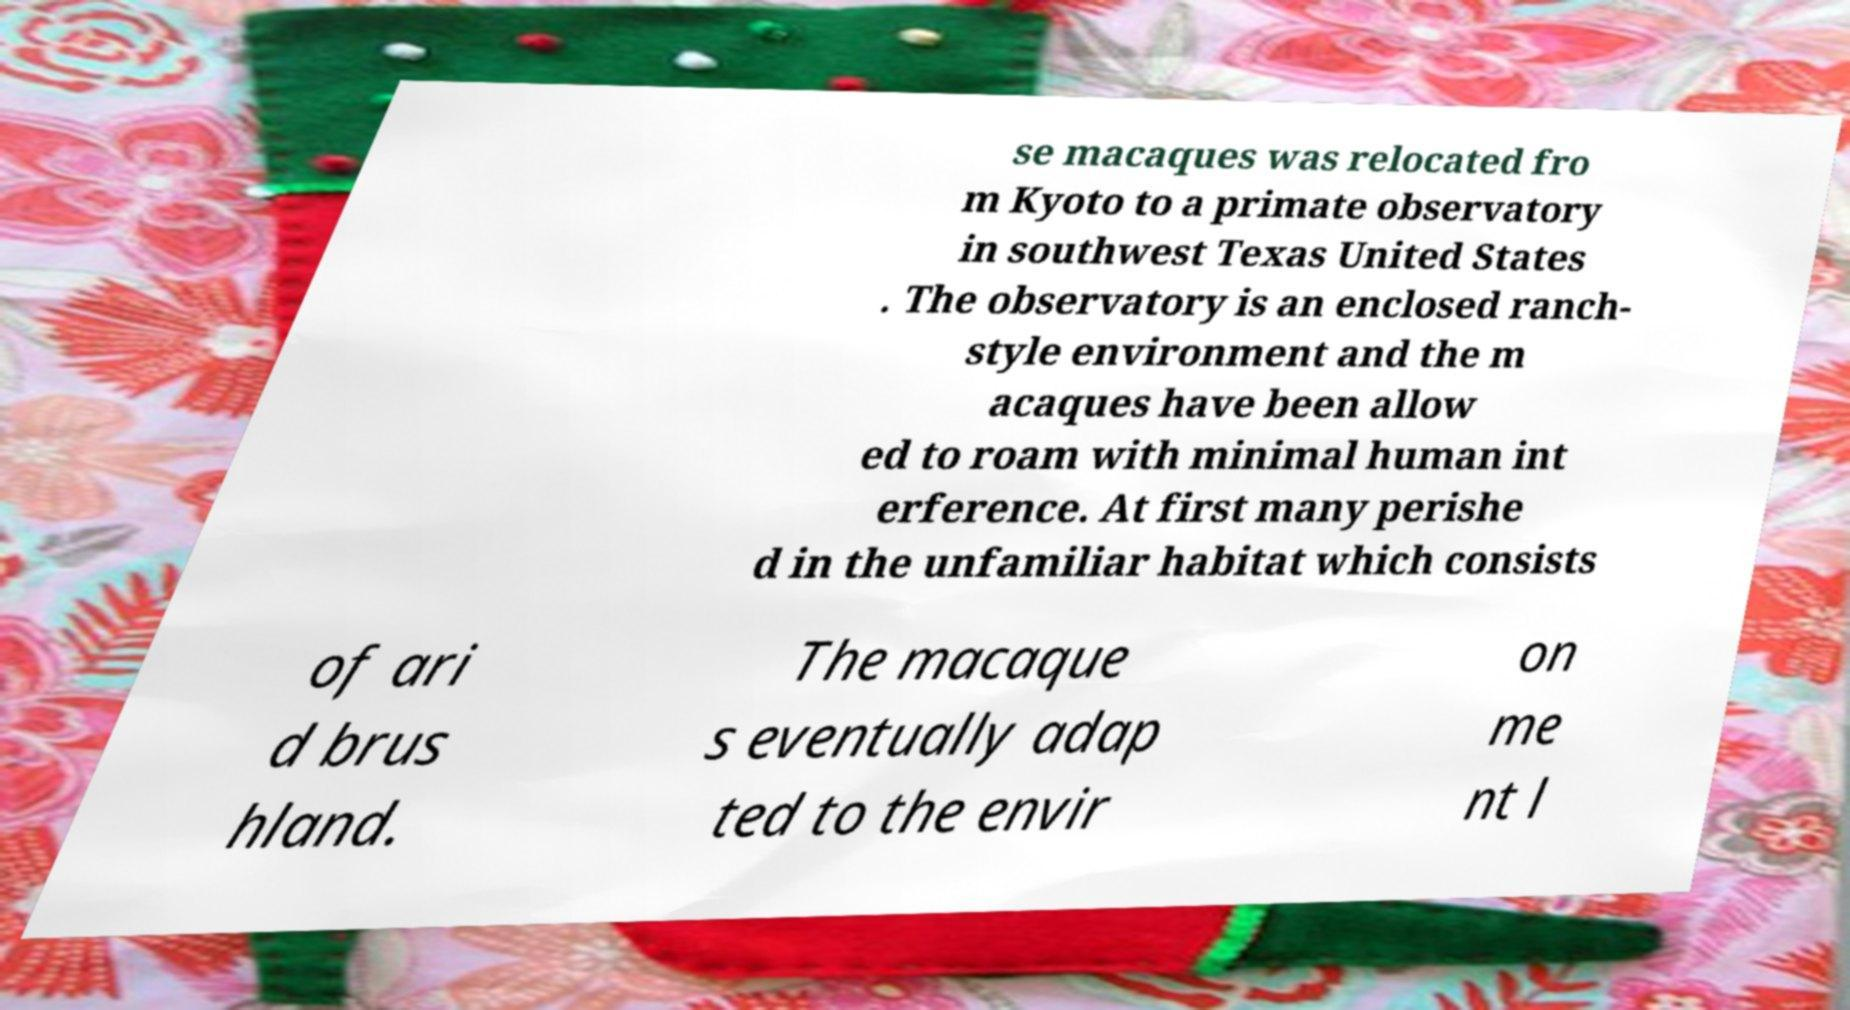Please read and relay the text visible in this image. What does it say? se macaques was relocated fro m Kyoto to a primate observatory in southwest Texas United States . The observatory is an enclosed ranch- style environment and the m acaques have been allow ed to roam with minimal human int erference. At first many perishe d in the unfamiliar habitat which consists of ari d brus hland. The macaque s eventually adap ted to the envir on me nt l 